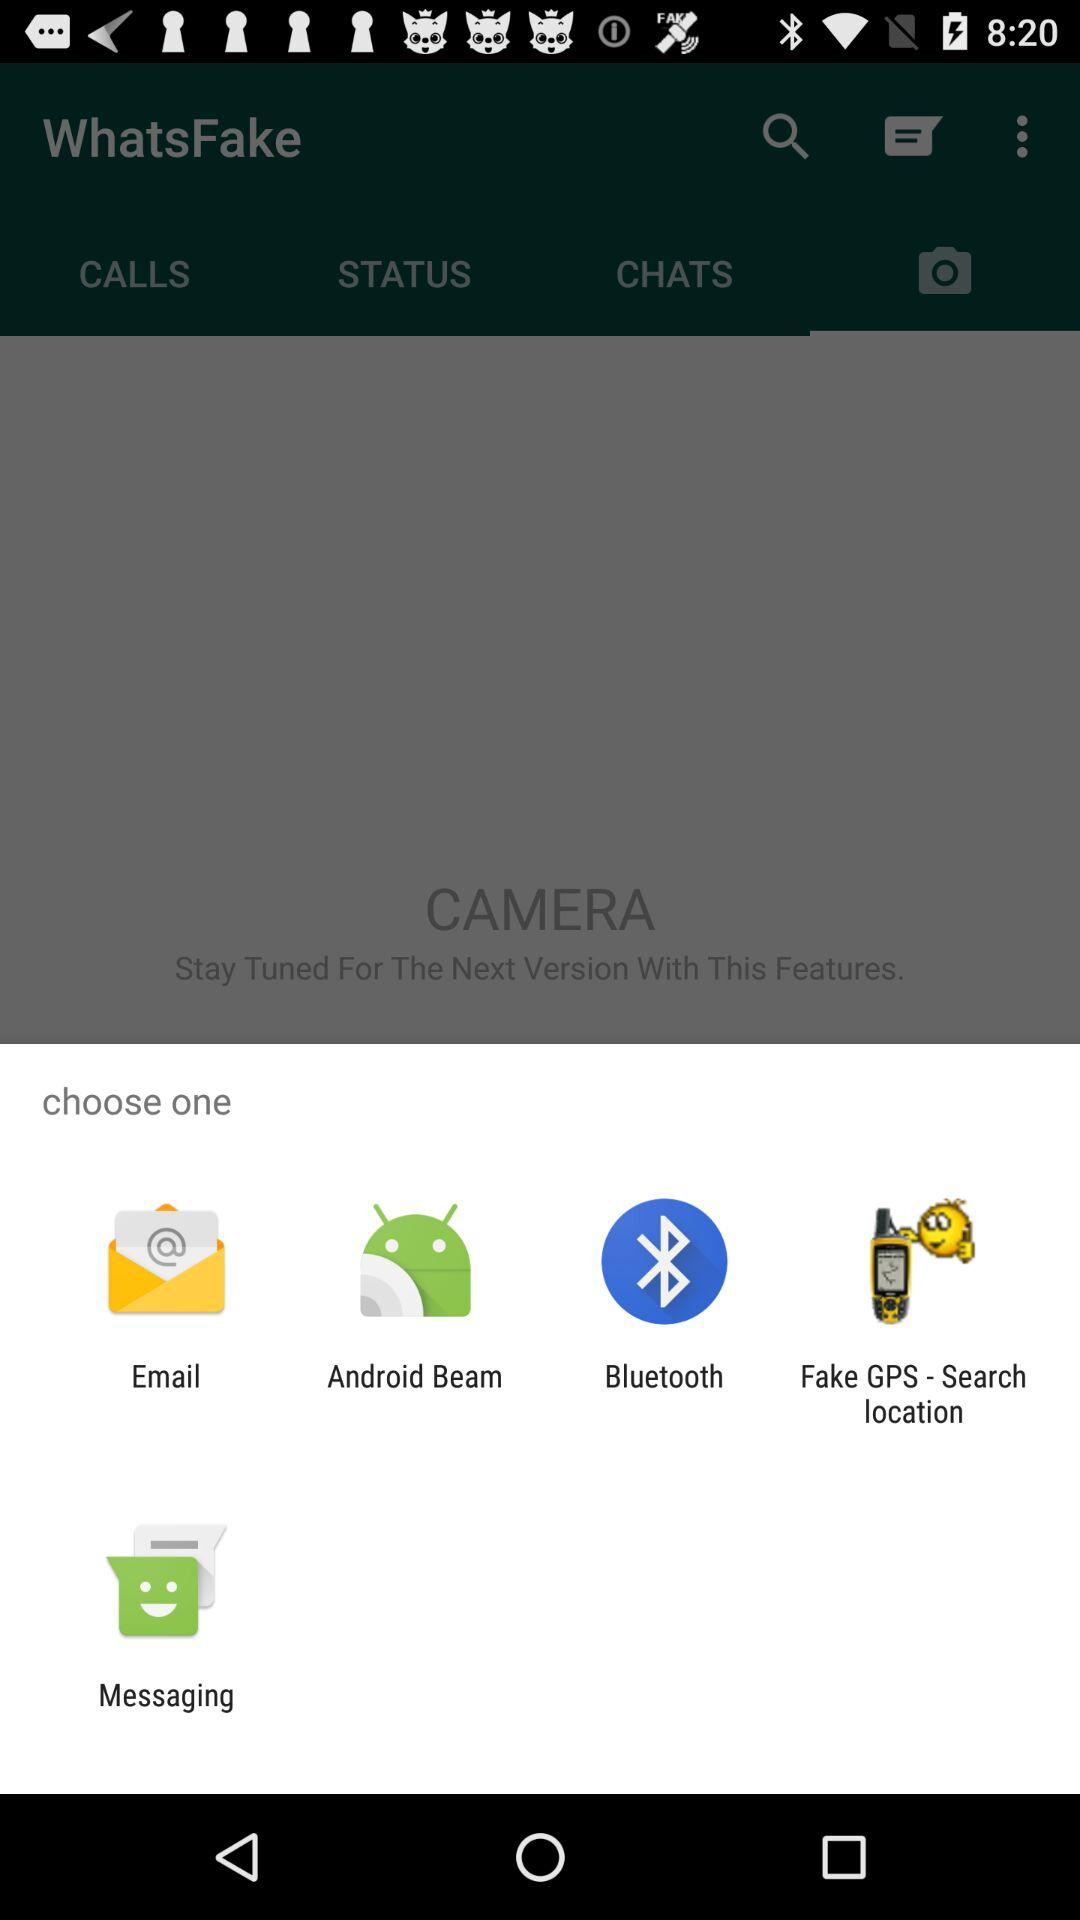Which are the different options to share? The different options to share are "Email", "Android Beam", "Bluetooth", "Fake GPS - Search location" and "Messaging". 